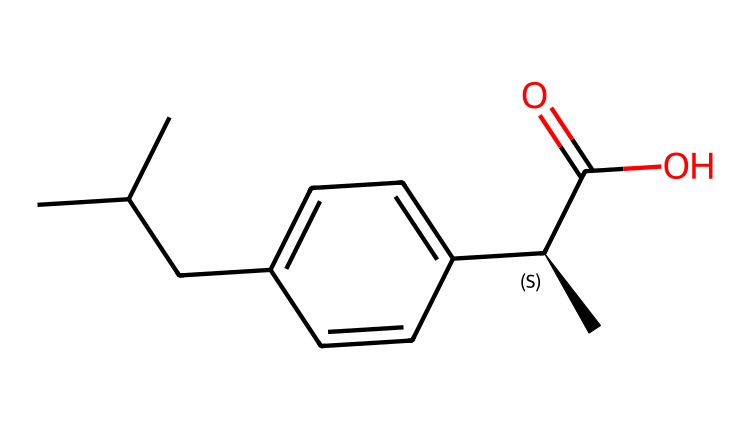How many chiral centers are present in ibuprofen? The structure of ibuprofen shows that there is one carbon atom bonded to four different substituents, which makes it a chiral center.
Answer: one What is the functional group present in ibuprofen? By examining the structure, the presence of the -COOH group indicates that ibuprofen contains a carboxylic acid functional group.
Answer: carboxylic acid What is the total number of carbon atoms in ibuprofen? Counting the carbon atoms in the given structure, there are 13 carbon atoms in total present in the molecule, including those in the chains and the ring.
Answer: thirteen What is the stereochemistry configuration at the chiral center in ibuprofen? The stereochemistry of the chiral center in ibuprofen is indicated by the '@' symbol in the SMILES notation, indicating it has an S configuration.
Answer: S Which part of the ibuprofen structure contributes to its anti-inflammatory properties? The presence of the carboxylic acid and the specific arrangement of the carbon chain and aromatic ring contribute to ibuprofen's mechanism in reducing inflammation.
Answer: carboxylic acid How many hydrogen atoms are in ibuprofen? By analyzing the structure and considering the tetravalency of carbon and the functional groups, there are 18 hydrogen atoms in the ibuprofen molecule.
Answer: eighteen Is ibuprofen a racemic mixture? Since ibuprofen has one chiral center and the compound can exist as both enantiomers, it is often marketed as a racemic mixture, containing equal parts of both enantiomers.
Answer: racemic mixture 